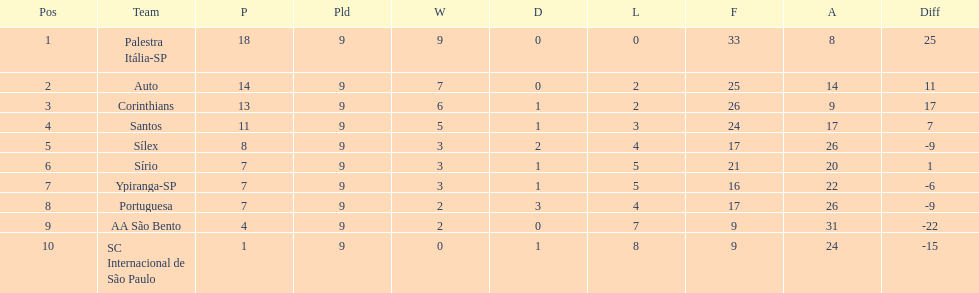How many points did the brazilian football team auto get in 1926? 14. 